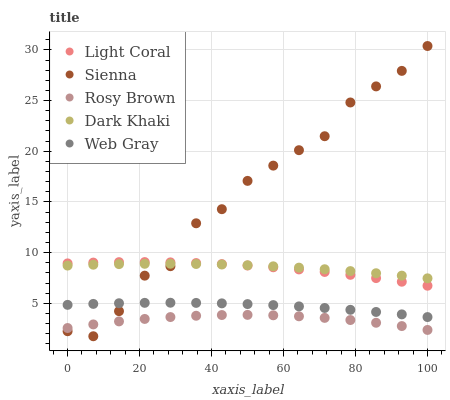Does Rosy Brown have the minimum area under the curve?
Answer yes or no. Yes. Does Sienna have the maximum area under the curve?
Answer yes or no. Yes. Does Sienna have the minimum area under the curve?
Answer yes or no. No. Does Rosy Brown have the maximum area under the curve?
Answer yes or no. No. Is Dark Khaki the smoothest?
Answer yes or no. Yes. Is Sienna the roughest?
Answer yes or no. Yes. Is Rosy Brown the smoothest?
Answer yes or no. No. Is Rosy Brown the roughest?
Answer yes or no. No. Does Sienna have the lowest value?
Answer yes or no. Yes. Does Rosy Brown have the lowest value?
Answer yes or no. No. Does Sienna have the highest value?
Answer yes or no. Yes. Does Rosy Brown have the highest value?
Answer yes or no. No. Is Web Gray less than Dark Khaki?
Answer yes or no. Yes. Is Dark Khaki greater than Web Gray?
Answer yes or no. Yes. Does Light Coral intersect Dark Khaki?
Answer yes or no. Yes. Is Light Coral less than Dark Khaki?
Answer yes or no. No. Is Light Coral greater than Dark Khaki?
Answer yes or no. No. Does Web Gray intersect Dark Khaki?
Answer yes or no. No. 